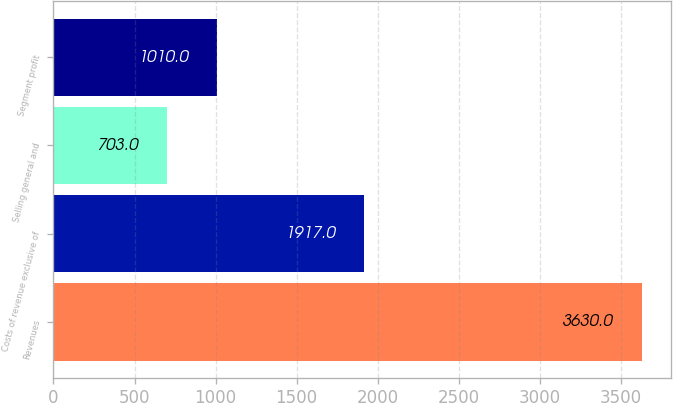Convert chart. <chart><loc_0><loc_0><loc_500><loc_500><bar_chart><fcel>Revenues<fcel>Costs of revenue exclusive of<fcel>Selling general and<fcel>Segment profit<nl><fcel>3630<fcel>1917<fcel>703<fcel>1010<nl></chart> 